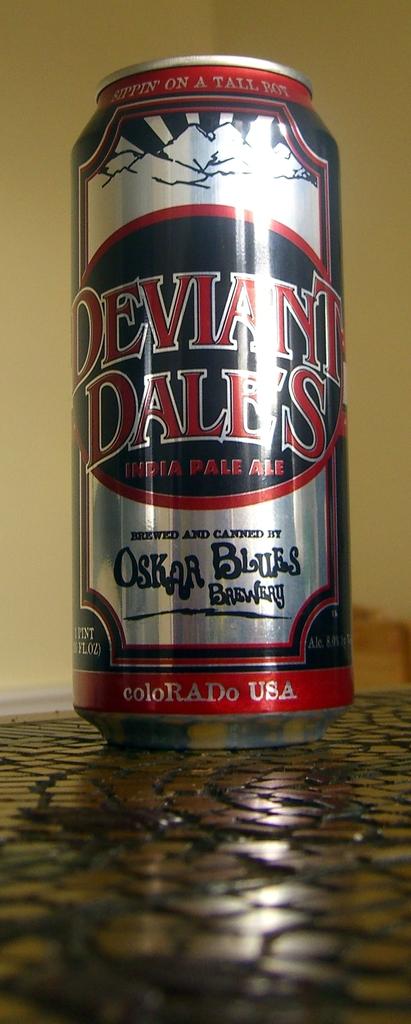Where is the beer from?
Your response must be concise. Colorado. 